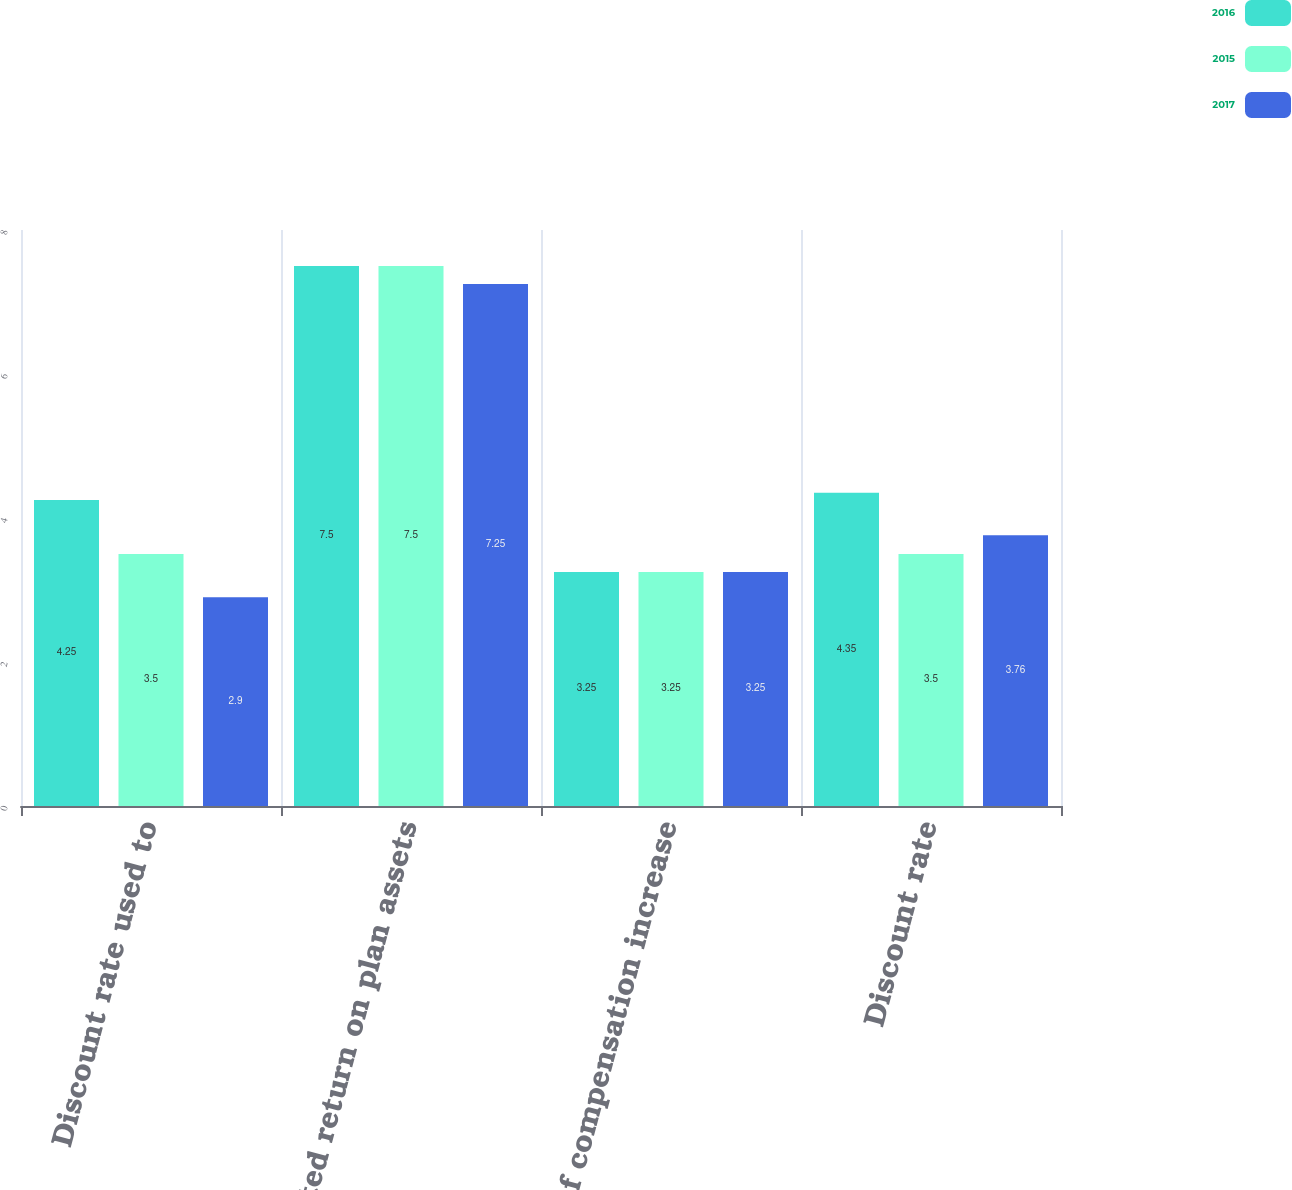<chart> <loc_0><loc_0><loc_500><loc_500><stacked_bar_chart><ecel><fcel>Discount rate used to<fcel>Expected return on plan assets<fcel>Rate of compensation increase<fcel>Discount rate<nl><fcel>2016<fcel>4.25<fcel>7.5<fcel>3.25<fcel>4.35<nl><fcel>2015<fcel>3.5<fcel>7.5<fcel>3.25<fcel>3.5<nl><fcel>2017<fcel>2.9<fcel>7.25<fcel>3.25<fcel>3.76<nl></chart> 